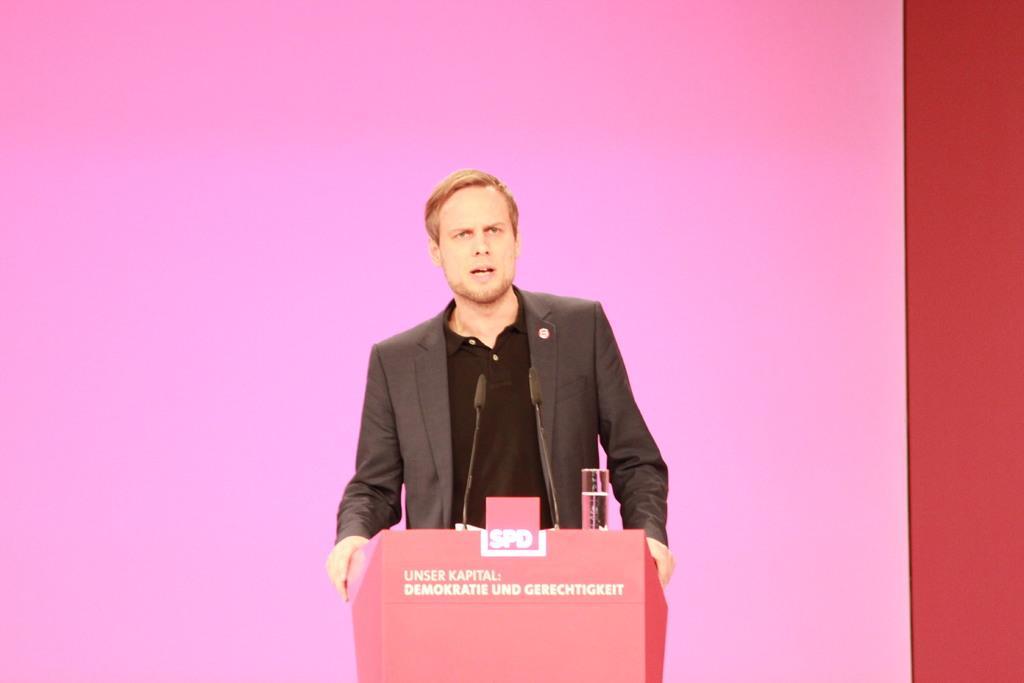How would you summarize this image in a sentence or two? In this image, we can see a person on the pink background. There is a podium at the bottom of the image. 